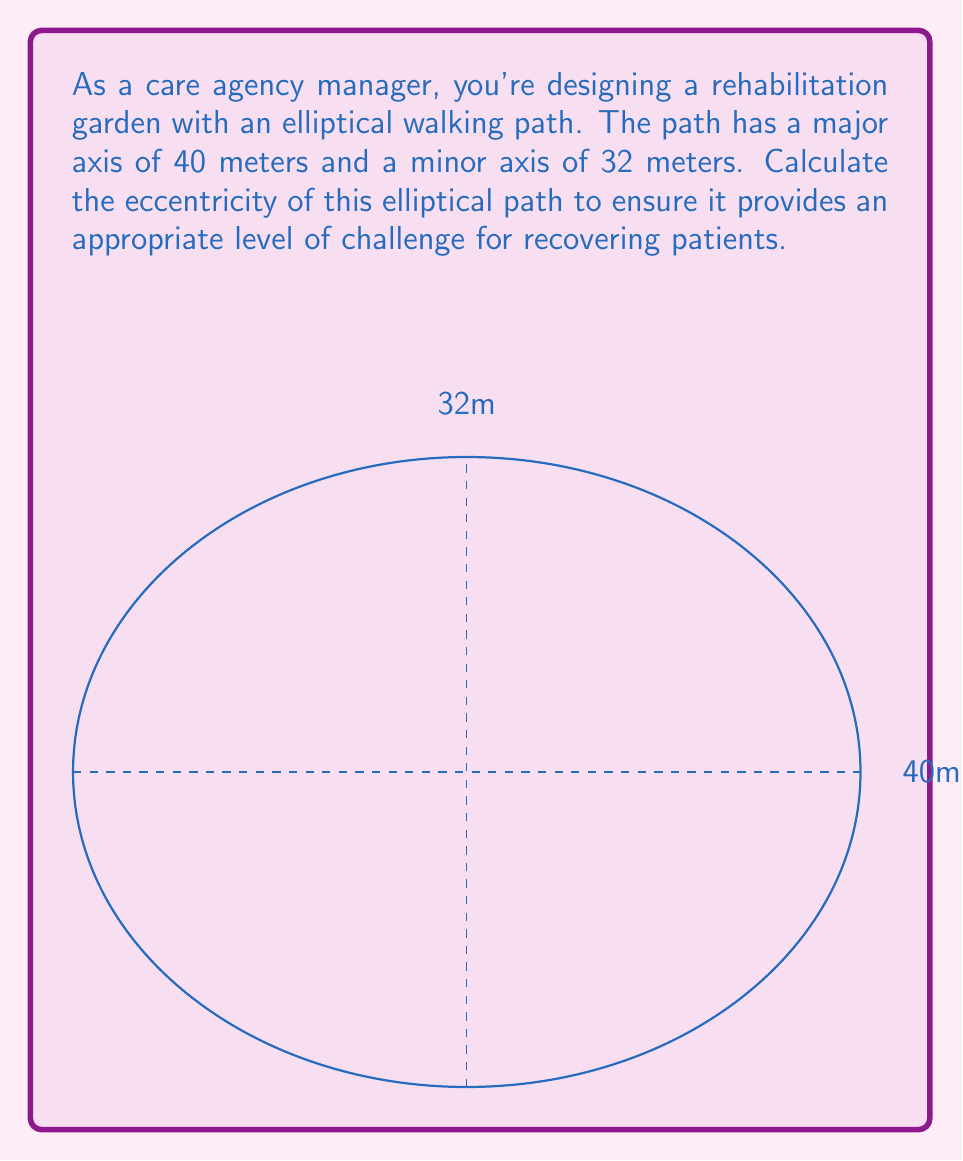Provide a solution to this math problem. To find the eccentricity of an ellipse, we need to follow these steps:

1) Recall the formula for eccentricity: $e = \sqrt{1 - \frac{b^2}{a^2}}$
   where $a$ is the semi-major axis and $b$ is the semi-minor axis.

2) In this case, we're given the full lengths of the axes:
   Major axis = 40 meters
   Minor axis = 32 meters

3) We need to halve these to get the semi-axes:
   $a = 40/2 = 20$ meters
   $b = 32/2 = 16$ meters

4) Now we can substitute these values into our eccentricity formula:

   $e = \sqrt{1 - \frac{b^2}{a^2}}$

   $e = \sqrt{1 - \frac{16^2}{20^2}}$

5) Simplify inside the parentheses:
   $e = \sqrt{1 - \frac{256}{400}}$

6) Perform the division:
   $e = \sqrt{1 - 0.64}$

7) Subtract:
   $e = \sqrt{0.36}$

8) Take the square root:
   $e = 0.6$

The eccentricity of the elliptical path is 0.6, which indicates a moderately elongated ellipse, providing a balanced challenge for recovering patients.
Answer: $0.6$ 